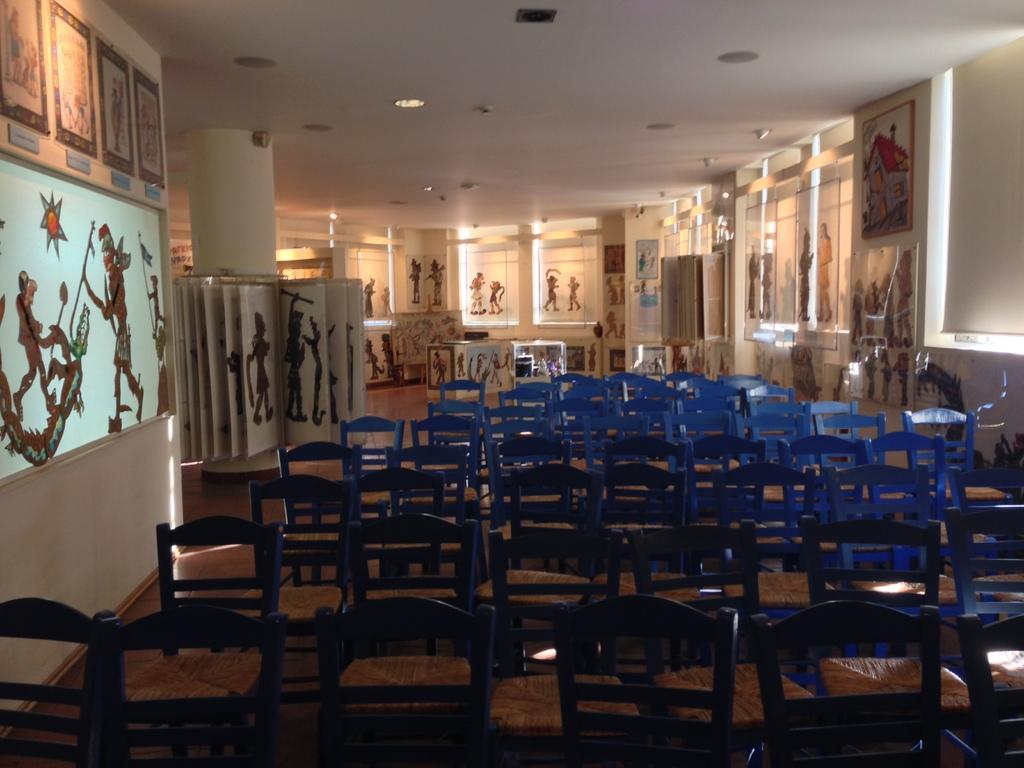What type of furniture is present in the image? There are chairs in the image. What color are the chairs? The chairs are blue. What can be seen attached to the wall in the image? There are frames attached to the wall in the image. What architectural feature is visible in the image? There is a window in the image. What is the color of the wall in the image? The wall is cream-colored. Can you see a monkey looking out the window in the image? There is no monkey present in the image, nor is there any indication of a monkey looking out the window. 